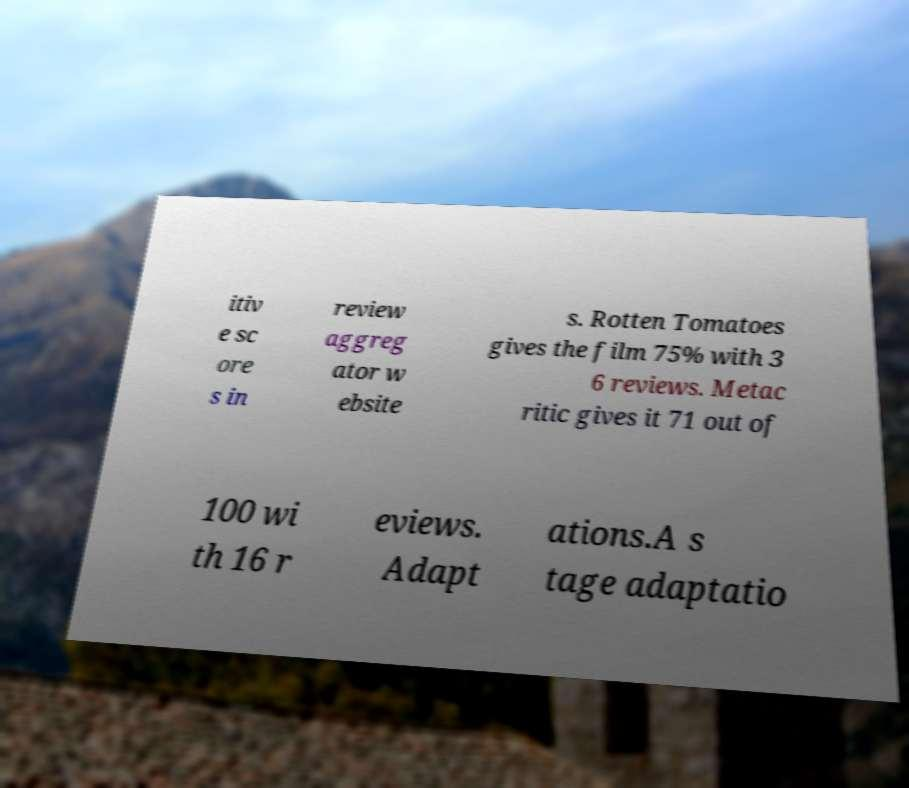What messages or text are displayed in this image? I need them in a readable, typed format. itiv e sc ore s in review aggreg ator w ebsite s. Rotten Tomatoes gives the film 75% with 3 6 reviews. Metac ritic gives it 71 out of 100 wi th 16 r eviews. Adapt ations.A s tage adaptatio 